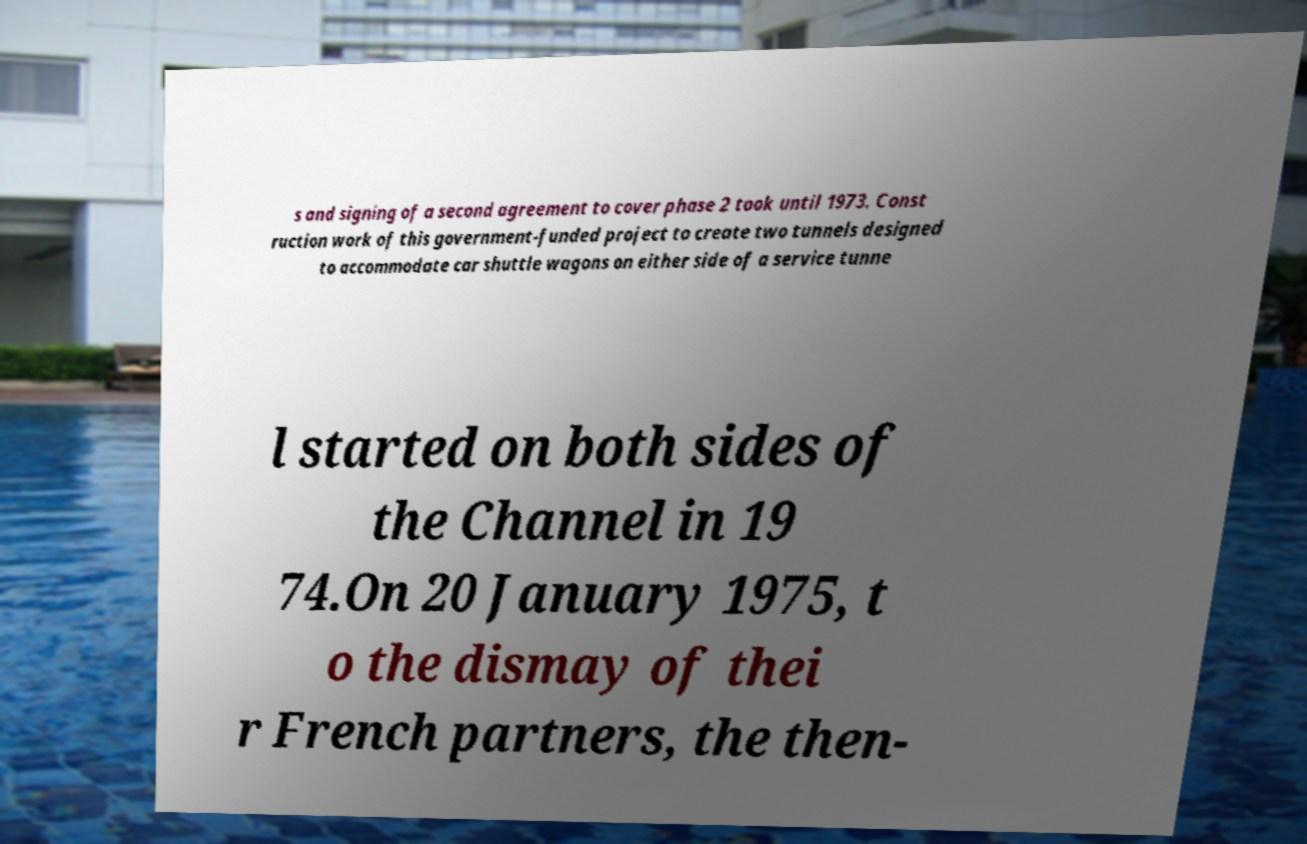I need the written content from this picture converted into text. Can you do that? s and signing of a second agreement to cover phase 2 took until 1973. Const ruction work of this government-funded project to create two tunnels designed to accommodate car shuttle wagons on either side of a service tunne l started on both sides of the Channel in 19 74.On 20 January 1975, t o the dismay of thei r French partners, the then- 